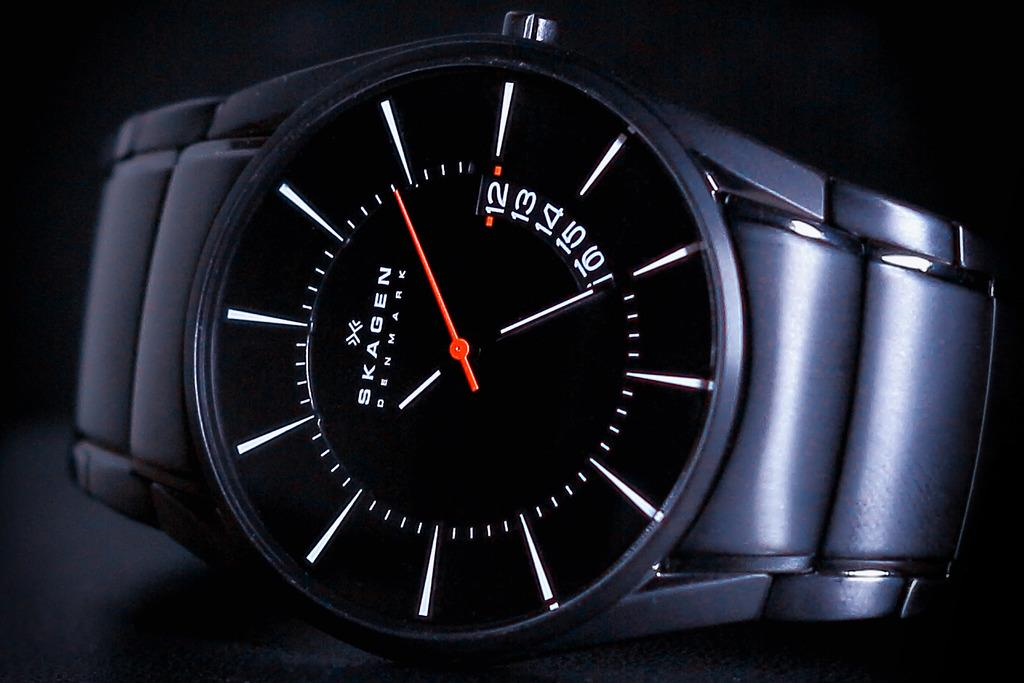Provide a one-sentence caption for the provided image. Black and white wristwatch which says SKAGEN on it. 